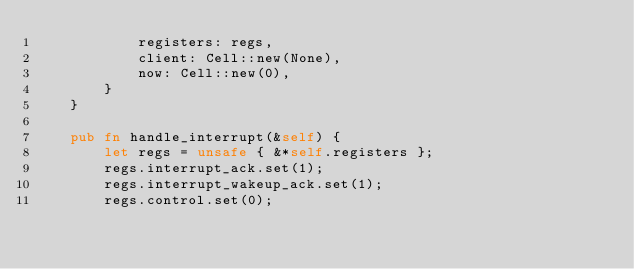Convert code to text. <code><loc_0><loc_0><loc_500><loc_500><_Rust_>            registers: regs,
            client: Cell::new(None),
            now: Cell::new(0),
        }
    }

    pub fn handle_interrupt(&self) {
        let regs = unsafe { &*self.registers };
        regs.interrupt_ack.set(1);
        regs.interrupt_wakeup_ack.set(1);
        regs.control.set(0);</code> 